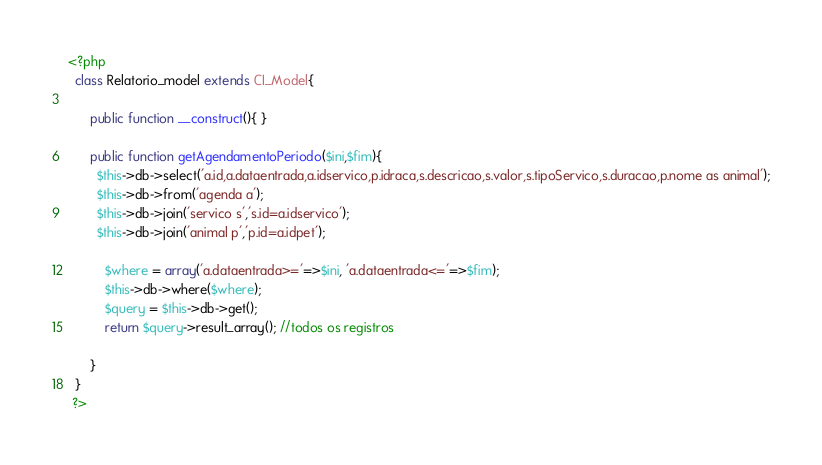<code> <loc_0><loc_0><loc_500><loc_500><_PHP_><?php
  class Relatorio_model extends CI_Model{

      public function __construct(){ }

      public function getAgendamentoPeriodo($ini,$fim){
        $this->db->select('a.id,a.dataentrada,a.idservico,p.idraca,s.descricao,s.valor,s.tipoServico,s.duracao,p.nome as animal');
        $this->db->from('agenda a');
        $this->db->join('servico s','s.id=a.idservico');
        $this->db->join('animal p','p.id=a.idpet');

          $where = array('a.dataentrada>='=>$ini, 'a.dataentrada<='=>$fim);
          $this->db->where($where);
          $query = $this->db->get();
          return $query->result_array(); //todos os registros

      }
  }
 ?>
</code> 